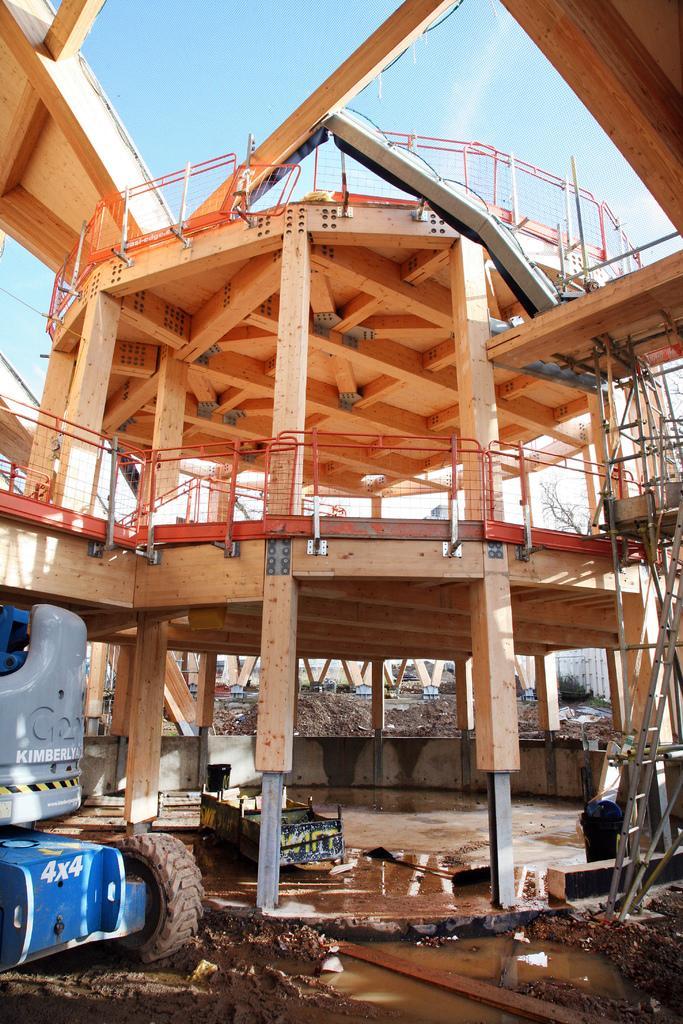In one or two sentences, can you explain what this image depicts? In this image there is a crane, in the background there is a construction of a building and there is the sky. 